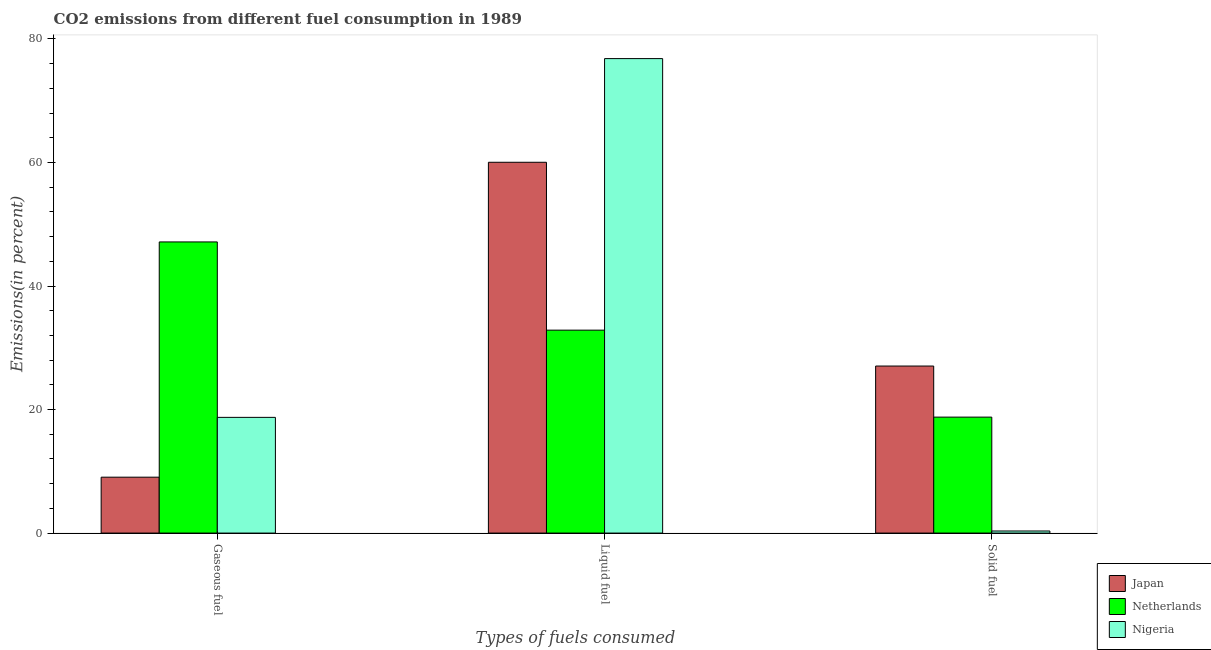How many bars are there on the 3rd tick from the left?
Your answer should be very brief. 3. How many bars are there on the 2nd tick from the right?
Make the answer very short. 3. What is the label of the 2nd group of bars from the left?
Keep it short and to the point. Liquid fuel. What is the percentage of liquid fuel emission in Nigeria?
Offer a terse response. 76.82. Across all countries, what is the maximum percentage of gaseous fuel emission?
Keep it short and to the point. 47.14. Across all countries, what is the minimum percentage of liquid fuel emission?
Give a very brief answer. 32.85. In which country was the percentage of gaseous fuel emission maximum?
Offer a terse response. Netherlands. In which country was the percentage of gaseous fuel emission minimum?
Provide a short and direct response. Japan. What is the total percentage of liquid fuel emission in the graph?
Your response must be concise. 169.71. What is the difference between the percentage of solid fuel emission in Netherlands and that in Nigeria?
Offer a very short reply. 18.44. What is the difference between the percentage of gaseous fuel emission in Netherlands and the percentage of solid fuel emission in Japan?
Your response must be concise. 20.09. What is the average percentage of solid fuel emission per country?
Make the answer very short. 15.38. What is the difference between the percentage of liquid fuel emission and percentage of solid fuel emission in Netherlands?
Your response must be concise. 14.08. In how many countries, is the percentage of solid fuel emission greater than 16 %?
Your answer should be very brief. 2. What is the ratio of the percentage of solid fuel emission in Japan to that in Nigeria?
Give a very brief answer. 80.25. Is the percentage of solid fuel emission in Japan less than that in Netherlands?
Offer a terse response. No. What is the difference between the highest and the second highest percentage of gaseous fuel emission?
Your response must be concise. 28.4. What is the difference between the highest and the lowest percentage of liquid fuel emission?
Your answer should be compact. 43.96. In how many countries, is the percentage of liquid fuel emission greater than the average percentage of liquid fuel emission taken over all countries?
Make the answer very short. 2. What does the 3rd bar from the left in Gaseous fuel represents?
Your response must be concise. Nigeria. What does the 2nd bar from the right in Gaseous fuel represents?
Offer a terse response. Netherlands. Is it the case that in every country, the sum of the percentage of gaseous fuel emission and percentage of liquid fuel emission is greater than the percentage of solid fuel emission?
Offer a very short reply. Yes. How many countries are there in the graph?
Make the answer very short. 3. Are the values on the major ticks of Y-axis written in scientific E-notation?
Your response must be concise. No. Does the graph contain grids?
Give a very brief answer. No. How are the legend labels stacked?
Your answer should be compact. Vertical. What is the title of the graph?
Ensure brevity in your answer.  CO2 emissions from different fuel consumption in 1989. What is the label or title of the X-axis?
Your answer should be very brief. Types of fuels consumed. What is the label or title of the Y-axis?
Your response must be concise. Emissions(in percent). What is the Emissions(in percent) of Japan in Gaseous fuel?
Provide a short and direct response. 9.05. What is the Emissions(in percent) of Netherlands in Gaseous fuel?
Give a very brief answer. 47.14. What is the Emissions(in percent) in Nigeria in Gaseous fuel?
Provide a succinct answer. 18.73. What is the Emissions(in percent) in Japan in Liquid fuel?
Offer a very short reply. 60.03. What is the Emissions(in percent) in Netherlands in Liquid fuel?
Provide a short and direct response. 32.85. What is the Emissions(in percent) of Nigeria in Liquid fuel?
Give a very brief answer. 76.82. What is the Emissions(in percent) of Japan in Solid fuel?
Your answer should be compact. 27.04. What is the Emissions(in percent) of Netherlands in Solid fuel?
Keep it short and to the point. 18.77. What is the Emissions(in percent) in Nigeria in Solid fuel?
Ensure brevity in your answer.  0.34. Across all Types of fuels consumed, what is the maximum Emissions(in percent) in Japan?
Your answer should be compact. 60.03. Across all Types of fuels consumed, what is the maximum Emissions(in percent) in Netherlands?
Offer a terse response. 47.14. Across all Types of fuels consumed, what is the maximum Emissions(in percent) in Nigeria?
Offer a very short reply. 76.82. Across all Types of fuels consumed, what is the minimum Emissions(in percent) of Japan?
Give a very brief answer. 9.05. Across all Types of fuels consumed, what is the minimum Emissions(in percent) in Netherlands?
Provide a succinct answer. 18.77. Across all Types of fuels consumed, what is the minimum Emissions(in percent) in Nigeria?
Make the answer very short. 0.34. What is the total Emissions(in percent) of Japan in the graph?
Make the answer very short. 96.12. What is the total Emissions(in percent) of Netherlands in the graph?
Make the answer very short. 98.76. What is the total Emissions(in percent) in Nigeria in the graph?
Your answer should be very brief. 95.89. What is the difference between the Emissions(in percent) in Japan in Gaseous fuel and that in Liquid fuel?
Give a very brief answer. -50.98. What is the difference between the Emissions(in percent) in Netherlands in Gaseous fuel and that in Liquid fuel?
Offer a terse response. 14.28. What is the difference between the Emissions(in percent) in Nigeria in Gaseous fuel and that in Liquid fuel?
Offer a very short reply. -58.09. What is the difference between the Emissions(in percent) of Japan in Gaseous fuel and that in Solid fuel?
Provide a short and direct response. -17.99. What is the difference between the Emissions(in percent) in Netherlands in Gaseous fuel and that in Solid fuel?
Your answer should be very brief. 28.36. What is the difference between the Emissions(in percent) of Nigeria in Gaseous fuel and that in Solid fuel?
Keep it short and to the point. 18.39. What is the difference between the Emissions(in percent) in Japan in Liquid fuel and that in Solid fuel?
Offer a terse response. 32.99. What is the difference between the Emissions(in percent) in Netherlands in Liquid fuel and that in Solid fuel?
Your answer should be compact. 14.08. What is the difference between the Emissions(in percent) in Nigeria in Liquid fuel and that in Solid fuel?
Provide a short and direct response. 76.48. What is the difference between the Emissions(in percent) of Japan in Gaseous fuel and the Emissions(in percent) of Netherlands in Liquid fuel?
Your answer should be compact. -23.81. What is the difference between the Emissions(in percent) of Japan in Gaseous fuel and the Emissions(in percent) of Nigeria in Liquid fuel?
Offer a very short reply. -67.77. What is the difference between the Emissions(in percent) in Netherlands in Gaseous fuel and the Emissions(in percent) in Nigeria in Liquid fuel?
Give a very brief answer. -29.68. What is the difference between the Emissions(in percent) in Japan in Gaseous fuel and the Emissions(in percent) in Netherlands in Solid fuel?
Offer a terse response. -9.72. What is the difference between the Emissions(in percent) of Japan in Gaseous fuel and the Emissions(in percent) of Nigeria in Solid fuel?
Offer a very short reply. 8.71. What is the difference between the Emissions(in percent) of Netherlands in Gaseous fuel and the Emissions(in percent) of Nigeria in Solid fuel?
Provide a short and direct response. 46.8. What is the difference between the Emissions(in percent) of Japan in Liquid fuel and the Emissions(in percent) of Netherlands in Solid fuel?
Give a very brief answer. 41.26. What is the difference between the Emissions(in percent) of Japan in Liquid fuel and the Emissions(in percent) of Nigeria in Solid fuel?
Provide a succinct answer. 59.7. What is the difference between the Emissions(in percent) in Netherlands in Liquid fuel and the Emissions(in percent) in Nigeria in Solid fuel?
Offer a terse response. 32.52. What is the average Emissions(in percent) of Japan per Types of fuels consumed?
Make the answer very short. 32.04. What is the average Emissions(in percent) of Netherlands per Types of fuels consumed?
Keep it short and to the point. 32.92. What is the average Emissions(in percent) of Nigeria per Types of fuels consumed?
Your answer should be compact. 31.96. What is the difference between the Emissions(in percent) of Japan and Emissions(in percent) of Netherlands in Gaseous fuel?
Offer a very short reply. -38.09. What is the difference between the Emissions(in percent) of Japan and Emissions(in percent) of Nigeria in Gaseous fuel?
Your response must be concise. -9.68. What is the difference between the Emissions(in percent) in Netherlands and Emissions(in percent) in Nigeria in Gaseous fuel?
Your response must be concise. 28.4. What is the difference between the Emissions(in percent) of Japan and Emissions(in percent) of Netherlands in Liquid fuel?
Your answer should be compact. 27.18. What is the difference between the Emissions(in percent) in Japan and Emissions(in percent) in Nigeria in Liquid fuel?
Offer a terse response. -16.79. What is the difference between the Emissions(in percent) of Netherlands and Emissions(in percent) of Nigeria in Liquid fuel?
Your answer should be very brief. -43.96. What is the difference between the Emissions(in percent) in Japan and Emissions(in percent) in Netherlands in Solid fuel?
Keep it short and to the point. 8.27. What is the difference between the Emissions(in percent) in Japan and Emissions(in percent) in Nigeria in Solid fuel?
Give a very brief answer. 26.71. What is the difference between the Emissions(in percent) in Netherlands and Emissions(in percent) in Nigeria in Solid fuel?
Your answer should be very brief. 18.44. What is the ratio of the Emissions(in percent) in Japan in Gaseous fuel to that in Liquid fuel?
Offer a terse response. 0.15. What is the ratio of the Emissions(in percent) in Netherlands in Gaseous fuel to that in Liquid fuel?
Your answer should be very brief. 1.43. What is the ratio of the Emissions(in percent) in Nigeria in Gaseous fuel to that in Liquid fuel?
Your response must be concise. 0.24. What is the ratio of the Emissions(in percent) in Japan in Gaseous fuel to that in Solid fuel?
Ensure brevity in your answer.  0.33. What is the ratio of the Emissions(in percent) of Netherlands in Gaseous fuel to that in Solid fuel?
Your answer should be very brief. 2.51. What is the ratio of the Emissions(in percent) in Nigeria in Gaseous fuel to that in Solid fuel?
Your response must be concise. 55.59. What is the ratio of the Emissions(in percent) of Japan in Liquid fuel to that in Solid fuel?
Make the answer very short. 2.22. What is the ratio of the Emissions(in percent) of Netherlands in Liquid fuel to that in Solid fuel?
Your response must be concise. 1.75. What is the ratio of the Emissions(in percent) of Nigeria in Liquid fuel to that in Solid fuel?
Your answer should be very brief. 227.97. What is the difference between the highest and the second highest Emissions(in percent) of Japan?
Provide a succinct answer. 32.99. What is the difference between the highest and the second highest Emissions(in percent) of Netherlands?
Keep it short and to the point. 14.28. What is the difference between the highest and the second highest Emissions(in percent) in Nigeria?
Provide a succinct answer. 58.09. What is the difference between the highest and the lowest Emissions(in percent) in Japan?
Offer a terse response. 50.98. What is the difference between the highest and the lowest Emissions(in percent) in Netherlands?
Give a very brief answer. 28.36. What is the difference between the highest and the lowest Emissions(in percent) in Nigeria?
Provide a succinct answer. 76.48. 